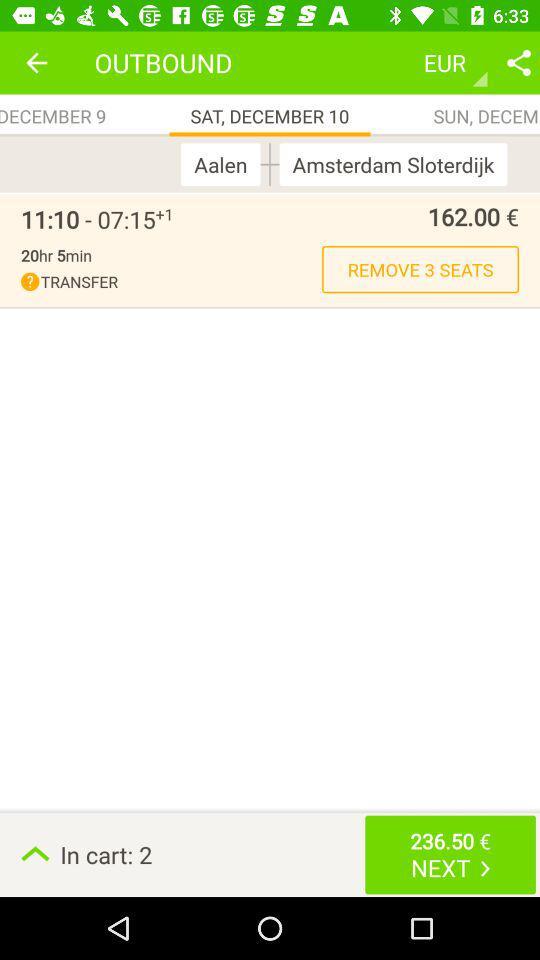Which city is the journey from to which city? The journey is from Aalen to Amsterdam Sloterdijk. 